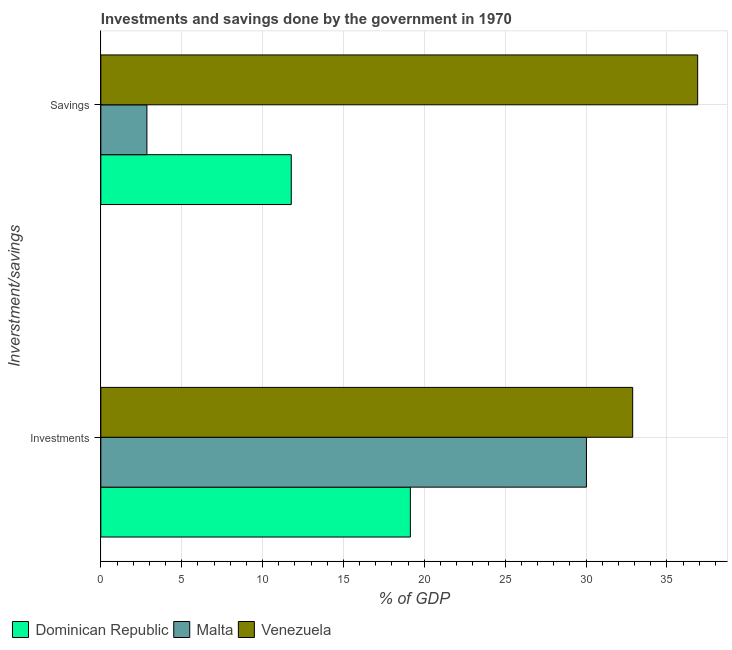Are the number of bars per tick equal to the number of legend labels?
Give a very brief answer. Yes. How many bars are there on the 1st tick from the top?
Make the answer very short. 3. How many bars are there on the 2nd tick from the bottom?
Offer a very short reply. 3. What is the label of the 2nd group of bars from the top?
Offer a very short reply. Investments. What is the savings of government in Venezuela?
Your answer should be very brief. 36.9. Across all countries, what is the maximum investments of government?
Give a very brief answer. 32.89. Across all countries, what is the minimum savings of government?
Your answer should be compact. 2.85. In which country was the savings of government maximum?
Keep it short and to the point. Venezuela. In which country was the investments of government minimum?
Your answer should be compact. Dominican Republic. What is the total savings of government in the graph?
Your answer should be very brief. 51.53. What is the difference between the investments of government in Dominican Republic and that in Venezuela?
Ensure brevity in your answer.  -13.75. What is the difference between the investments of government in Malta and the savings of government in Venezuela?
Your answer should be compact. -6.88. What is the average investments of government per country?
Give a very brief answer. 27.35. What is the difference between the investments of government and savings of government in Dominican Republic?
Give a very brief answer. 7.37. In how many countries, is the investments of government greater than 23 %?
Keep it short and to the point. 2. What is the ratio of the savings of government in Dominican Republic to that in Malta?
Offer a very short reply. 4.13. What does the 3rd bar from the top in Investments represents?
Provide a short and direct response. Dominican Republic. What does the 1st bar from the bottom in Savings represents?
Ensure brevity in your answer.  Dominican Republic. How many bars are there?
Make the answer very short. 6. How many countries are there in the graph?
Your answer should be compact. 3. How many legend labels are there?
Provide a succinct answer. 3. What is the title of the graph?
Ensure brevity in your answer.  Investments and savings done by the government in 1970. What is the label or title of the X-axis?
Ensure brevity in your answer.  % of GDP. What is the label or title of the Y-axis?
Your answer should be very brief. Inverstment/savings. What is the % of GDP of Dominican Republic in Investments?
Keep it short and to the point. 19.14. What is the % of GDP in Malta in Investments?
Your response must be concise. 30.03. What is the % of GDP of Venezuela in Investments?
Provide a short and direct response. 32.89. What is the % of GDP in Dominican Republic in Savings?
Your answer should be compact. 11.77. What is the % of GDP of Malta in Savings?
Your answer should be very brief. 2.85. What is the % of GDP of Venezuela in Savings?
Provide a succinct answer. 36.9. Across all Inverstment/savings, what is the maximum % of GDP in Dominican Republic?
Your answer should be very brief. 19.14. Across all Inverstment/savings, what is the maximum % of GDP of Malta?
Ensure brevity in your answer.  30.03. Across all Inverstment/savings, what is the maximum % of GDP of Venezuela?
Give a very brief answer. 36.9. Across all Inverstment/savings, what is the minimum % of GDP in Dominican Republic?
Offer a very short reply. 11.77. Across all Inverstment/savings, what is the minimum % of GDP of Malta?
Ensure brevity in your answer.  2.85. Across all Inverstment/savings, what is the minimum % of GDP of Venezuela?
Offer a very short reply. 32.89. What is the total % of GDP of Dominican Republic in the graph?
Your answer should be compact. 30.91. What is the total % of GDP in Malta in the graph?
Your response must be concise. 32.88. What is the total % of GDP of Venezuela in the graph?
Offer a very short reply. 69.79. What is the difference between the % of GDP of Dominican Republic in Investments and that in Savings?
Provide a succinct answer. 7.37. What is the difference between the % of GDP in Malta in Investments and that in Savings?
Offer a very short reply. 27.18. What is the difference between the % of GDP in Venezuela in Investments and that in Savings?
Ensure brevity in your answer.  -4.02. What is the difference between the % of GDP of Dominican Republic in Investments and the % of GDP of Malta in Savings?
Offer a terse response. 16.29. What is the difference between the % of GDP in Dominican Republic in Investments and the % of GDP in Venezuela in Savings?
Provide a succinct answer. -17.76. What is the difference between the % of GDP of Malta in Investments and the % of GDP of Venezuela in Savings?
Offer a very short reply. -6.88. What is the average % of GDP in Dominican Republic per Inverstment/savings?
Make the answer very short. 15.46. What is the average % of GDP of Malta per Inverstment/savings?
Give a very brief answer. 16.44. What is the average % of GDP in Venezuela per Inverstment/savings?
Ensure brevity in your answer.  34.9. What is the difference between the % of GDP in Dominican Republic and % of GDP in Malta in Investments?
Your answer should be compact. -10.89. What is the difference between the % of GDP in Dominican Republic and % of GDP in Venezuela in Investments?
Provide a short and direct response. -13.75. What is the difference between the % of GDP of Malta and % of GDP of Venezuela in Investments?
Give a very brief answer. -2.86. What is the difference between the % of GDP in Dominican Republic and % of GDP in Malta in Savings?
Give a very brief answer. 8.93. What is the difference between the % of GDP in Dominican Republic and % of GDP in Venezuela in Savings?
Provide a succinct answer. -25.13. What is the difference between the % of GDP of Malta and % of GDP of Venezuela in Savings?
Keep it short and to the point. -34.05. What is the ratio of the % of GDP of Dominican Republic in Investments to that in Savings?
Offer a terse response. 1.63. What is the ratio of the % of GDP in Malta in Investments to that in Savings?
Offer a terse response. 10.54. What is the ratio of the % of GDP in Venezuela in Investments to that in Savings?
Your response must be concise. 0.89. What is the difference between the highest and the second highest % of GDP of Dominican Republic?
Your answer should be compact. 7.37. What is the difference between the highest and the second highest % of GDP in Malta?
Ensure brevity in your answer.  27.18. What is the difference between the highest and the second highest % of GDP of Venezuela?
Provide a succinct answer. 4.02. What is the difference between the highest and the lowest % of GDP in Dominican Republic?
Make the answer very short. 7.37. What is the difference between the highest and the lowest % of GDP in Malta?
Offer a terse response. 27.18. What is the difference between the highest and the lowest % of GDP in Venezuela?
Offer a very short reply. 4.02. 